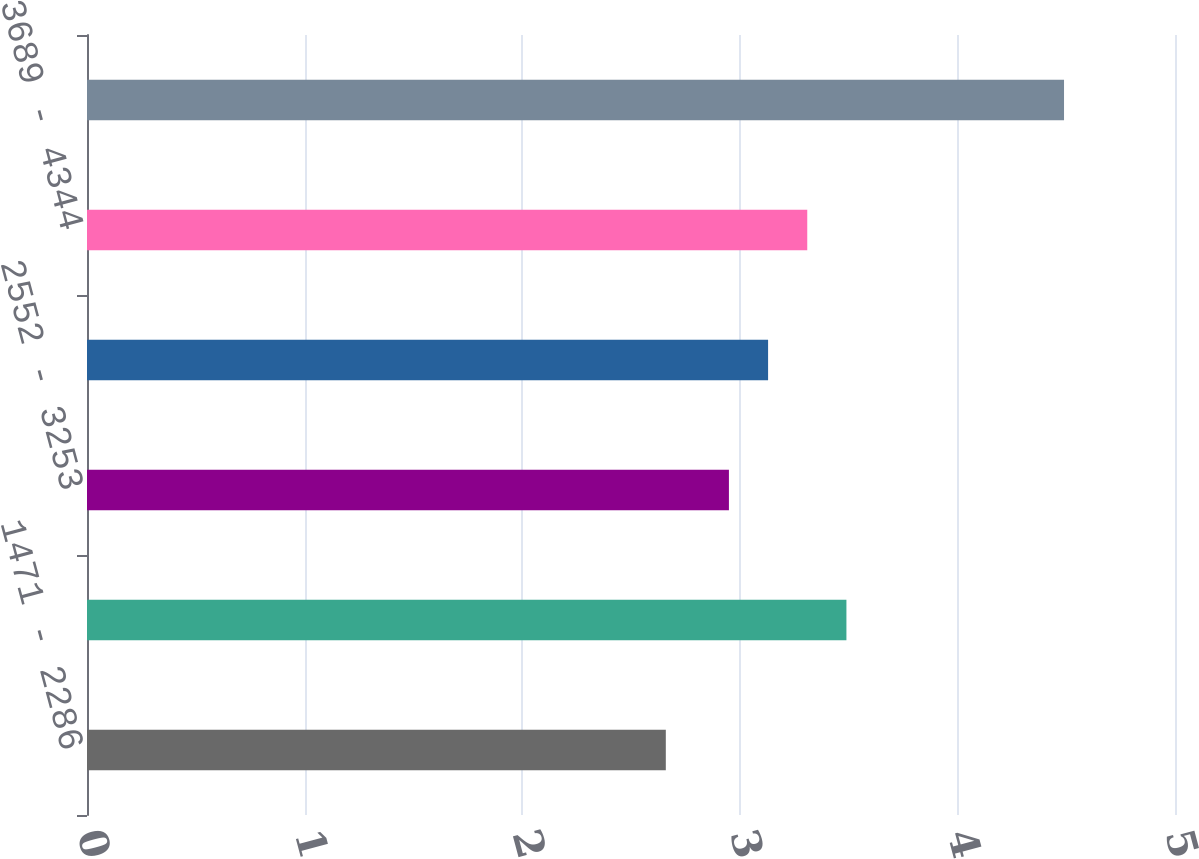Convert chart. <chart><loc_0><loc_0><loc_500><loc_500><bar_chart><fcel>1471 - 2286<fcel>2287 - 2551<fcel>2552 - 3253<fcel>3254 - 3688<fcel>3689 - 4344<fcel>4345 - 5293<nl><fcel>2.66<fcel>3.49<fcel>2.95<fcel>3.13<fcel>3.31<fcel>4.49<nl></chart> 